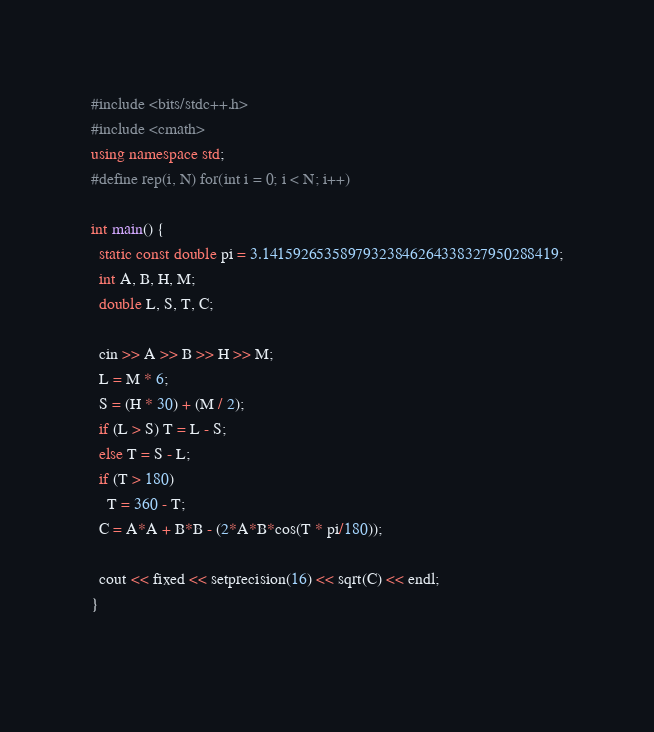Convert code to text. <code><loc_0><loc_0><loc_500><loc_500><_C++_>#include <bits/stdc++.h>
#include <cmath>
using namespace std;
#define rep(i, N) for(int i = 0; i < N; i++)

int main() {
  static const double pi = 3.14159265358979323846264338327950288419;
  int A, B, H, M;
  double L, S, T, C;
  
  cin >> A >> B >> H >> M;
  L = M * 6;
  S = (H * 30) + (M / 2);
  if (L > S) T = L - S;
  else T = S - L;
  if (T > 180)
    T = 360 - T;
  C = A*A + B*B - (2*A*B*cos(T * pi/180));

  cout << fixed << setprecision(16) << sqrt(C) << endl; 
}
    </code> 